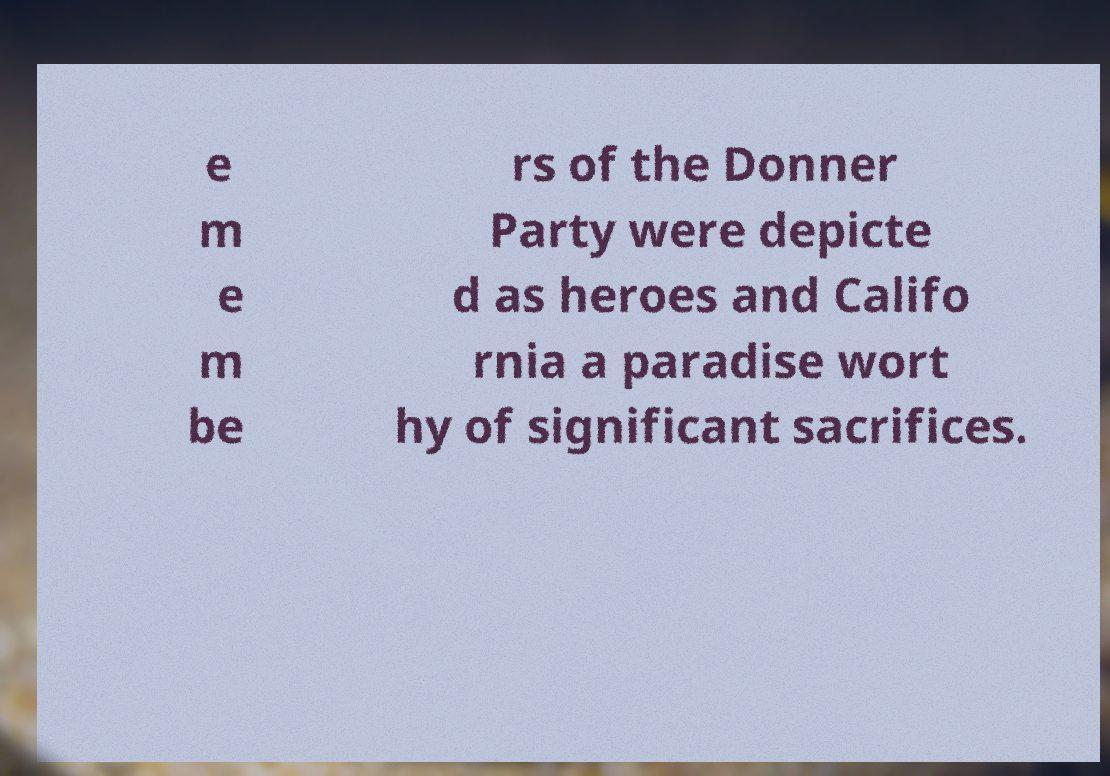Could you assist in decoding the text presented in this image and type it out clearly? e m e m be rs of the Donner Party were depicte d as heroes and Califo rnia a paradise wort hy of significant sacrifices. 